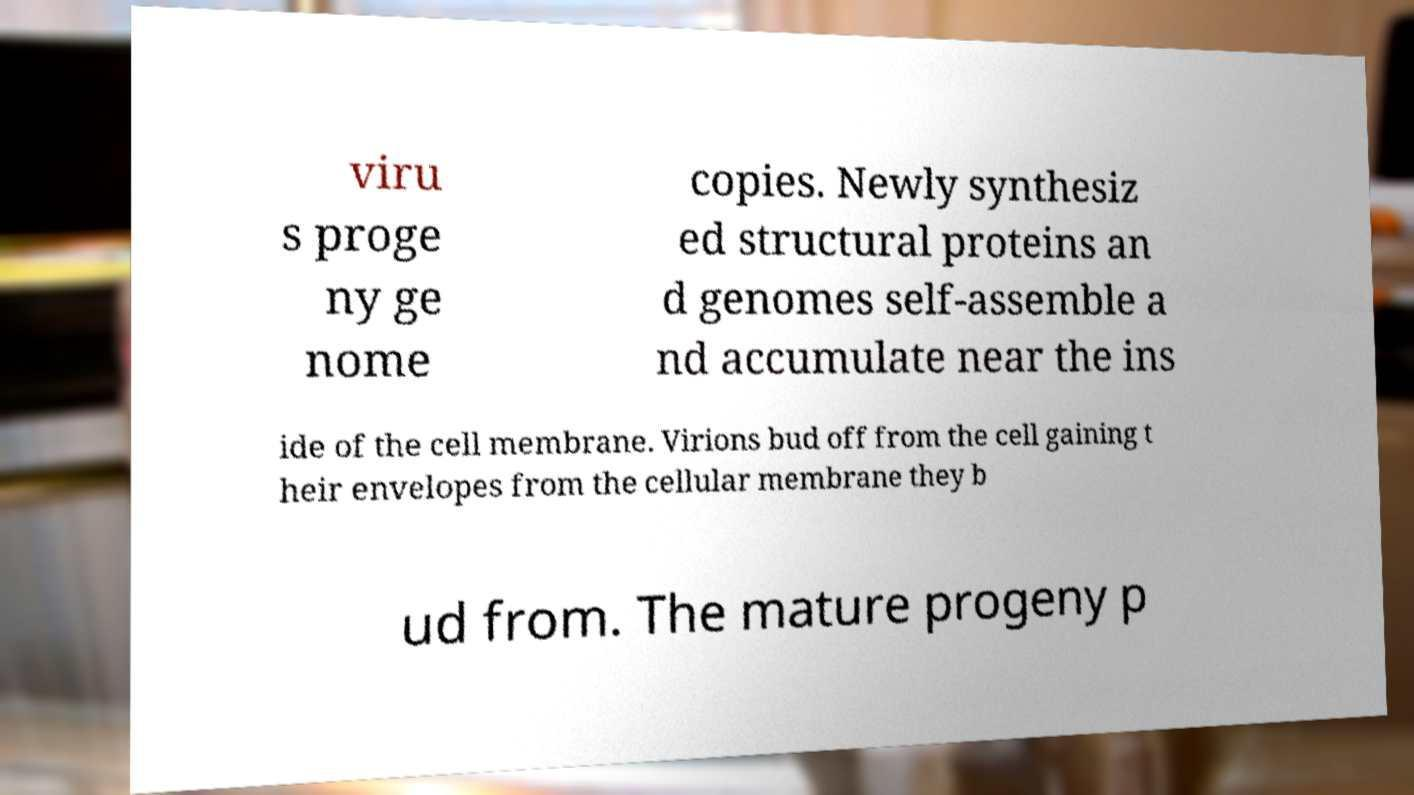Can you read and provide the text displayed in the image?This photo seems to have some interesting text. Can you extract and type it out for me? viru s proge ny ge nome copies. Newly synthesiz ed structural proteins an d genomes self-assemble a nd accumulate near the ins ide of the cell membrane. Virions bud off from the cell gaining t heir envelopes from the cellular membrane they b ud from. The mature progeny p 